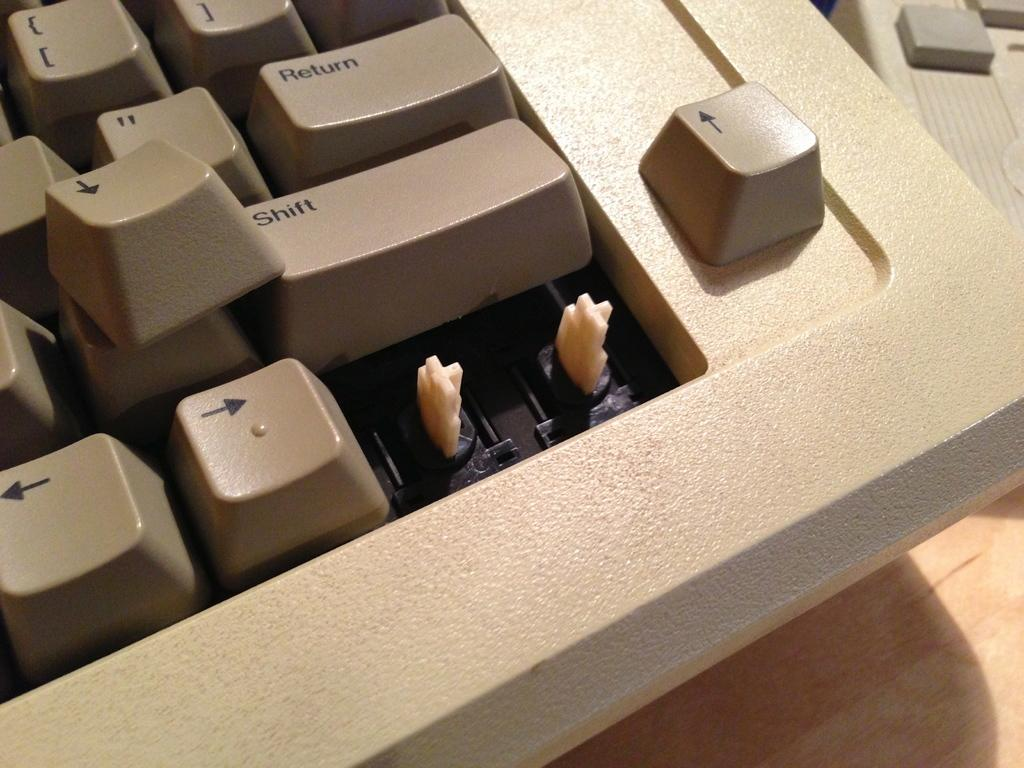Provide a one-sentence caption for the provided image. Computer keyboard with a Shift key under the Return key. 